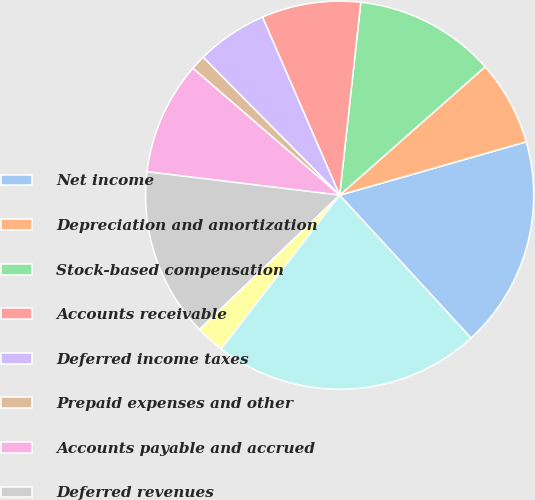Convert chart to OTSL. <chart><loc_0><loc_0><loc_500><loc_500><pie_chart><fcel>Net income<fcel>Depreciation and amortization<fcel>Stock-based compensation<fcel>Accounts receivable<fcel>Deferred income taxes<fcel>Prepaid expenses and other<fcel>Accounts payable and accrued<fcel>Deferred revenues<fcel>Accrued income taxes<fcel>Net cash provided by operating<nl><fcel>17.6%<fcel>7.08%<fcel>11.75%<fcel>8.25%<fcel>5.91%<fcel>1.23%<fcel>9.42%<fcel>14.09%<fcel>2.4%<fcel>22.28%<nl></chart> 